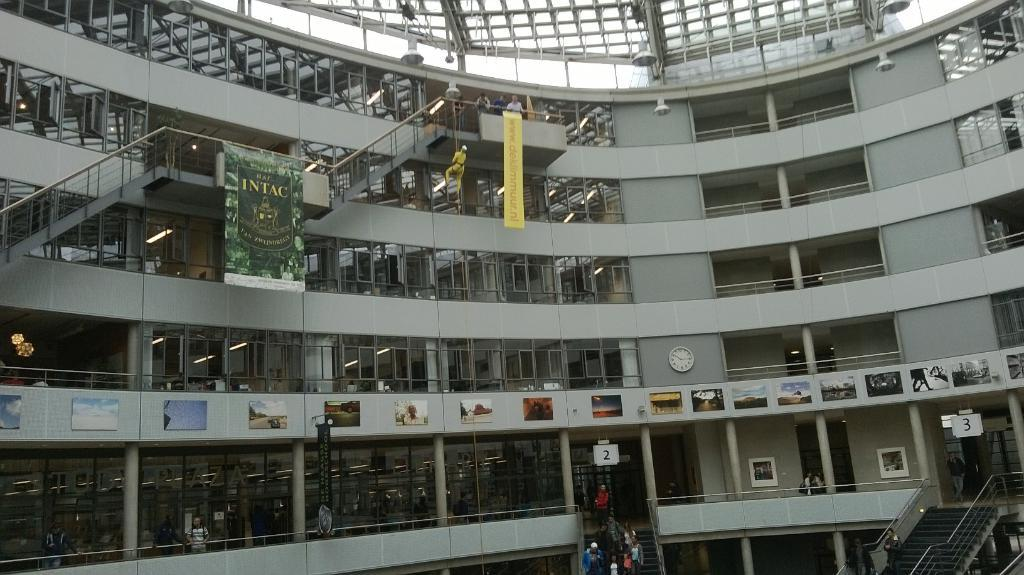What type of structure is shown in the image? There is a building in the image. What architectural feature is present in the building? Staircases are present in the image. What material is visible in the image? Boards and metal rods are visible in the image. What decorative elements are present in the image? Posters are present in the image. What part of the building is shown in the image? The image includes a rooftop. What time-keeping device is present in the image? A wall clock is present in the image. What access points are visible in the image? Doors are visible in the image. What lighting elements are present in the image? Lights are present in the image. How many people are visible in the image? There is a crowd in the image. How many fish can be seen swimming in the image? A: There are no fish present in the image; it features a building with various architectural elements and a crowd. What type of wood is used to construct the rooftop in the image? The image does not specify the type of wood used in the construction of the rooftop, nor does it show any wood in the image. 